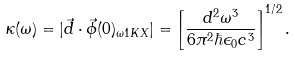Convert formula to latex. <formula><loc_0><loc_0><loc_500><loc_500>\kappa ( \omega ) = | \vec { d } \cdot \vec { \phi } ( 0 ) _ { \omega 1 K X } | = \left [ \frac { d ^ { 2 } \omega ^ { 3 } } { 6 \pi ^ { 2 } \hbar { \epsilon } _ { 0 } c ^ { 3 } } \right ] ^ { 1 / 2 } .</formula> 